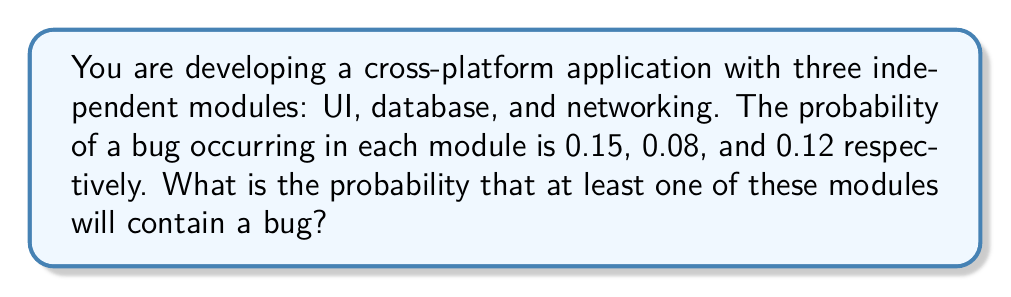Can you solve this math problem? Let's approach this step-by-step:

1) First, we need to calculate the probability that each module does not contain a bug:
   UI: $1 - 0.15 = 0.85$
   Database: $1 - 0.08 = 0.92$
   Networking: $1 - 0.12 = 0.88$

2) The probability that all modules are bug-free is the product of these probabilities:
   $P(\text{all bug-free}) = 0.85 \times 0.92 \times 0.88 = 0.6877$

3) The probability that at least one module contains a bug is the complement of the probability that all modules are bug-free:
   $P(\text{at least one bug}) = 1 - P(\text{all bug-free})$
   $= 1 - 0.6877 = 0.3123$

4) Therefore, the probability that at least one of these modules will contain a bug is approximately 0.3123 or 31.23%.
Answer: $0.3123$ or $31.23\%$ 